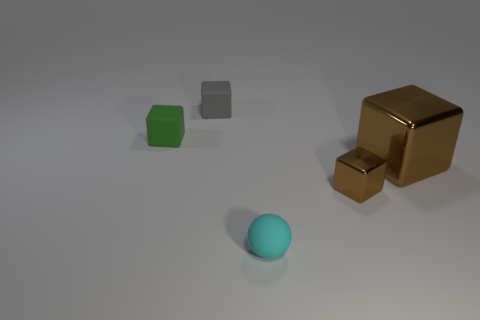There is a brown thing that is in front of the brown object behind the tiny cube that is on the right side of the small cyan matte ball; what is it made of?
Ensure brevity in your answer.  Metal. What size is the rubber thing that is on the right side of the green matte object and in front of the gray object?
Provide a short and direct response. Small. Do the small metal thing and the cyan object have the same shape?
Offer a terse response. No. The cyan object that is made of the same material as the small gray block is what shape?
Offer a very short reply. Sphere. How many large things are either cyan rubber objects or green objects?
Offer a terse response. 0. There is a cyan rubber ball that is on the right side of the gray matte thing; is there a tiny block left of it?
Provide a succinct answer. Yes. Are there any blue matte balls?
Your answer should be compact. No. What is the color of the metallic cube that is left of the metal cube that is right of the tiny brown shiny thing?
Give a very brief answer. Brown. What material is the gray object that is the same shape as the green thing?
Offer a terse response. Rubber. How many gray rubber objects have the same size as the green thing?
Your response must be concise. 1. 